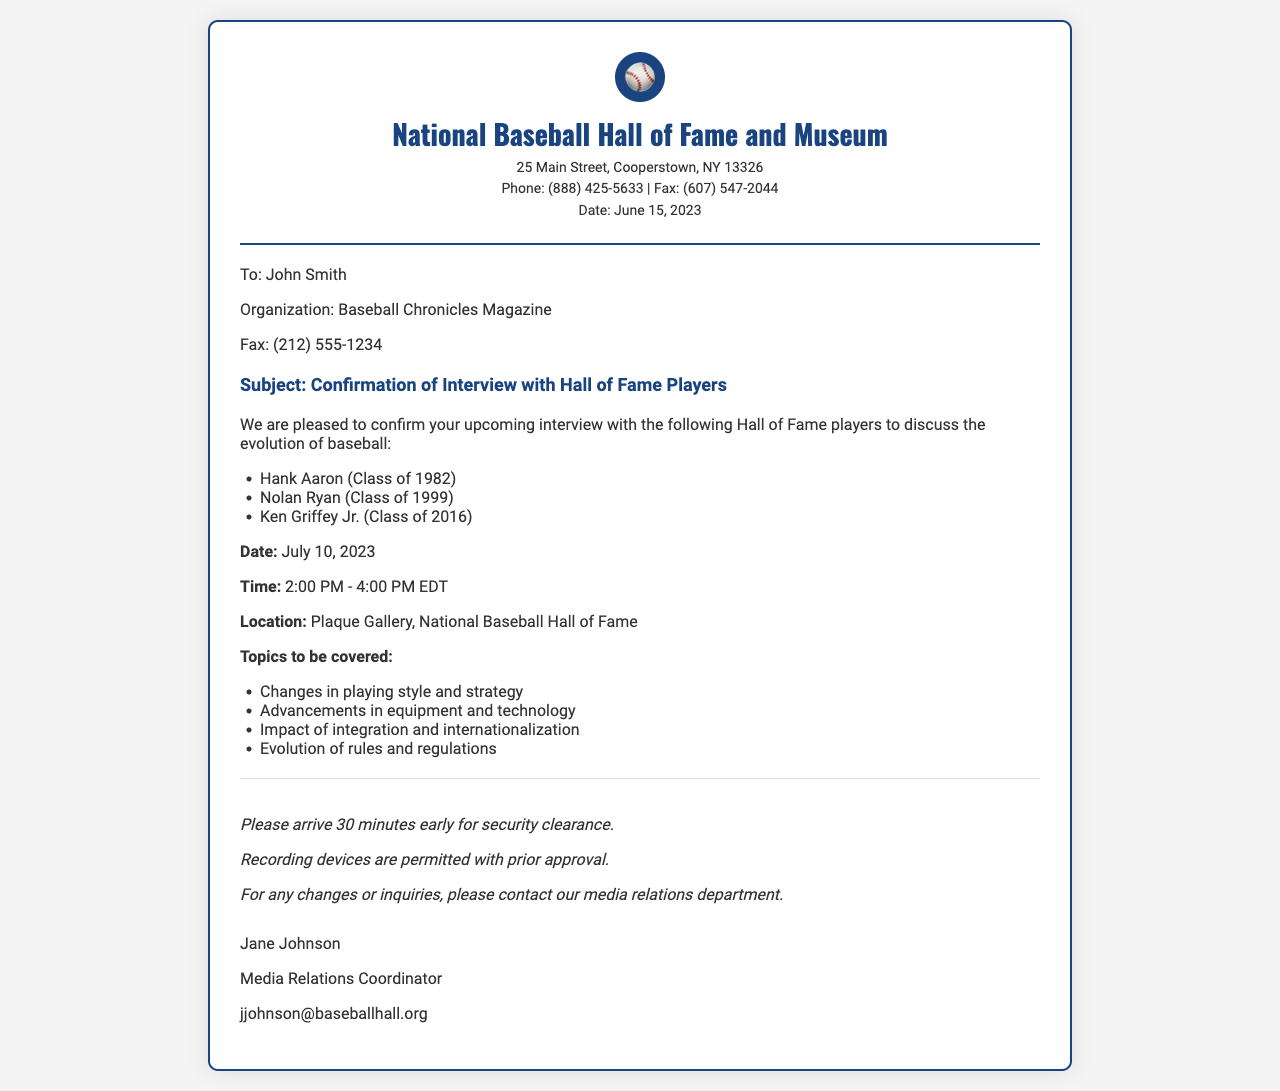What is the date of the fax? The date of the fax is specifically mentioned in the document as June 15, 2023.
Answer: June 15, 2023 Who is the recipient of the fax? The recipient's name and organization are listed clearly in the fax.
Answer: John Smith What three players are confirmed for the interview? The document specifies the names of the Hall of Fame players included in the interview confirmation.
Answer: Hank Aaron, Nolan Ryan, Ken Griffey Jr What time is the interview scheduled to start? The document directly states the scheduled time for the interview.
Answer: 2:00 PM What is the location of the interview? The document provides specific information about where the interview will take place.
Answer: Plaque Gallery, National Baseball Hall of Fame What topics will be covered during the interview? The fax enumerates the key topics that the interview will address, necessitating a summary of multiple items from the document.
Answer: Changes in playing style and strategy, advancements in equipment and technology, impact of integration and internationalization, evolution of rules and regulations How early should the interviewee arrive? The document advises on the expected arrival time for security clearance which indicates a specific duration.
Answer: 30 minutes early Who is the sender of the fax? The sender's name and position are included at the end of the document.
Answer: Jane Johnson 